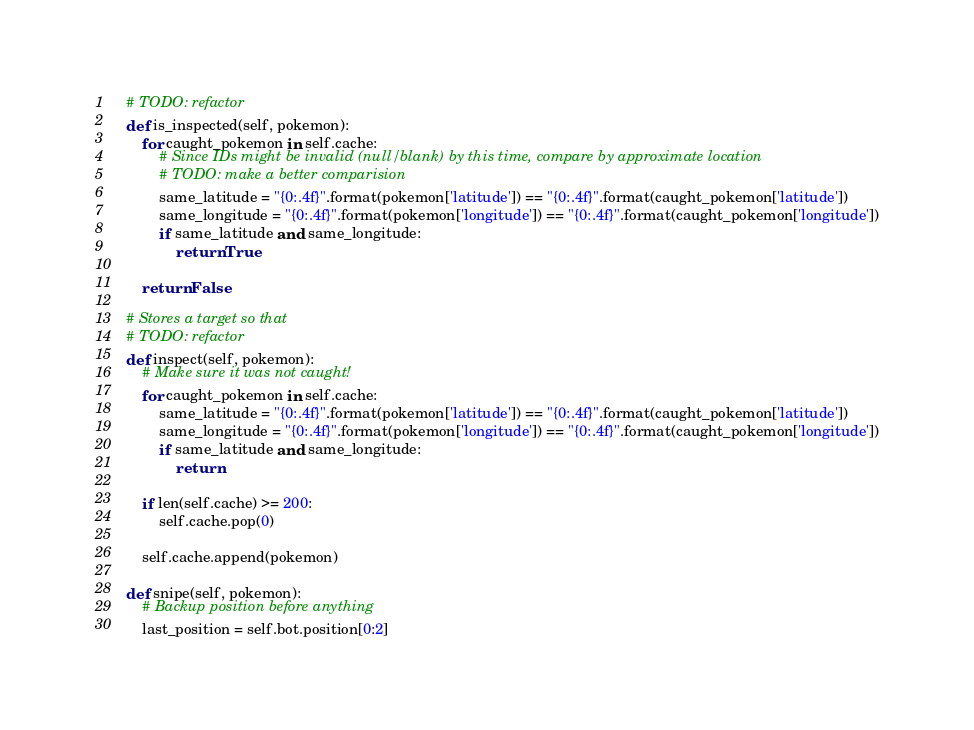Convert code to text. <code><loc_0><loc_0><loc_500><loc_500><_Python_>
    # TODO: refactor
    def is_inspected(self, pokemon):
        for caught_pokemon in self.cache:
            # Since IDs might be invalid (null/blank) by this time, compare by approximate location
            # TODO: make a better comparision
            same_latitude = "{0:.4f}".format(pokemon['latitude']) == "{0:.4f}".format(caught_pokemon['latitude'])
            same_longitude = "{0:.4f}".format(pokemon['longitude']) == "{0:.4f}".format(caught_pokemon['longitude'])
            if same_latitude and same_longitude:
                return True

        return False

    # Stores a target so that
    # TODO: refactor
    def inspect(self, pokemon):
        # Make sure it was not caught!
        for caught_pokemon in self.cache:
            same_latitude = "{0:.4f}".format(pokemon['latitude']) == "{0:.4f}".format(caught_pokemon['latitude'])
            same_longitude = "{0:.4f}".format(pokemon['longitude']) == "{0:.4f}".format(caught_pokemon['longitude'])
            if same_latitude and same_longitude:
                return

        if len(self.cache) >= 200:
            self.cache.pop(0)

        self.cache.append(pokemon)

    def snipe(self, pokemon):
        # Backup position before anything
        last_position = self.bot.position[0:2]
</code> 